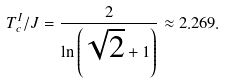<formula> <loc_0><loc_0><loc_500><loc_500>T _ { c } ^ { I } / J = \frac { 2 } { \ln \left ( \sqrt { 2 } + 1 \right ) } \approx 2 . 2 6 9 .</formula> 